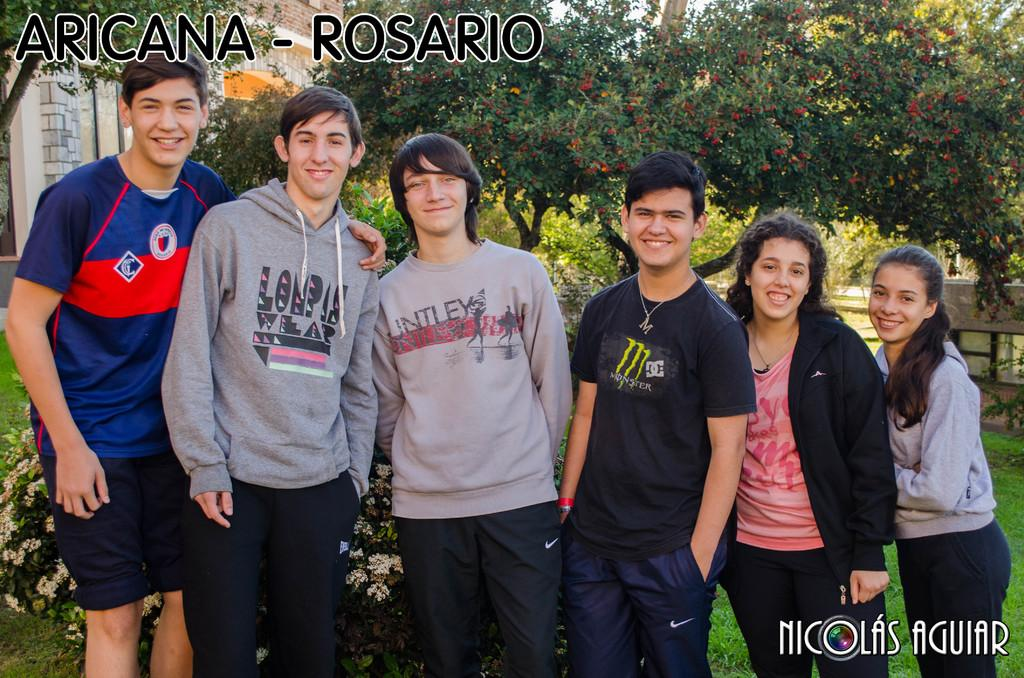What can be seen in the image? There are people standing in the image. What is visible in the background of the image? There are trees in the background of the image. Where is the text located in the image? There is text in the top left corner and the bottom right corner of the image. What type of toys are being played with by the people in the image? There are no toys visible in the image; it only shows people standing and text in the corners. 